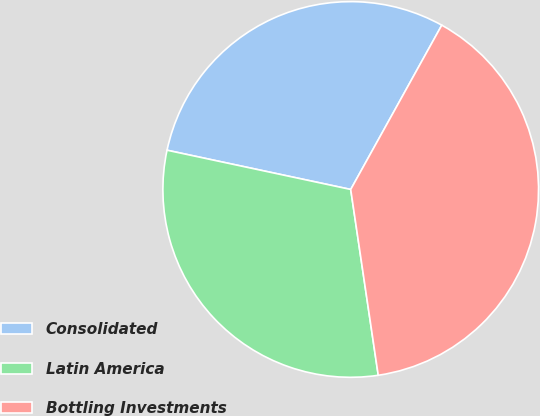Convert chart to OTSL. <chart><loc_0><loc_0><loc_500><loc_500><pie_chart><fcel>Consolidated<fcel>Latin America<fcel>Bottling Investments<nl><fcel>29.7%<fcel>30.69%<fcel>39.6%<nl></chart> 